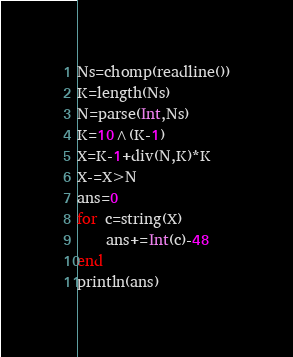<code> <loc_0><loc_0><loc_500><loc_500><_Julia_>Ns=chomp(readline())
K=length(Ns)
N=parse(Int,Ns)
K=10^(K-1)
X=K-1+div(N,K)*K
X-=X>N
ans=0
for c=string(X)
	ans+=Int(c)-48
end
println(ans)</code> 